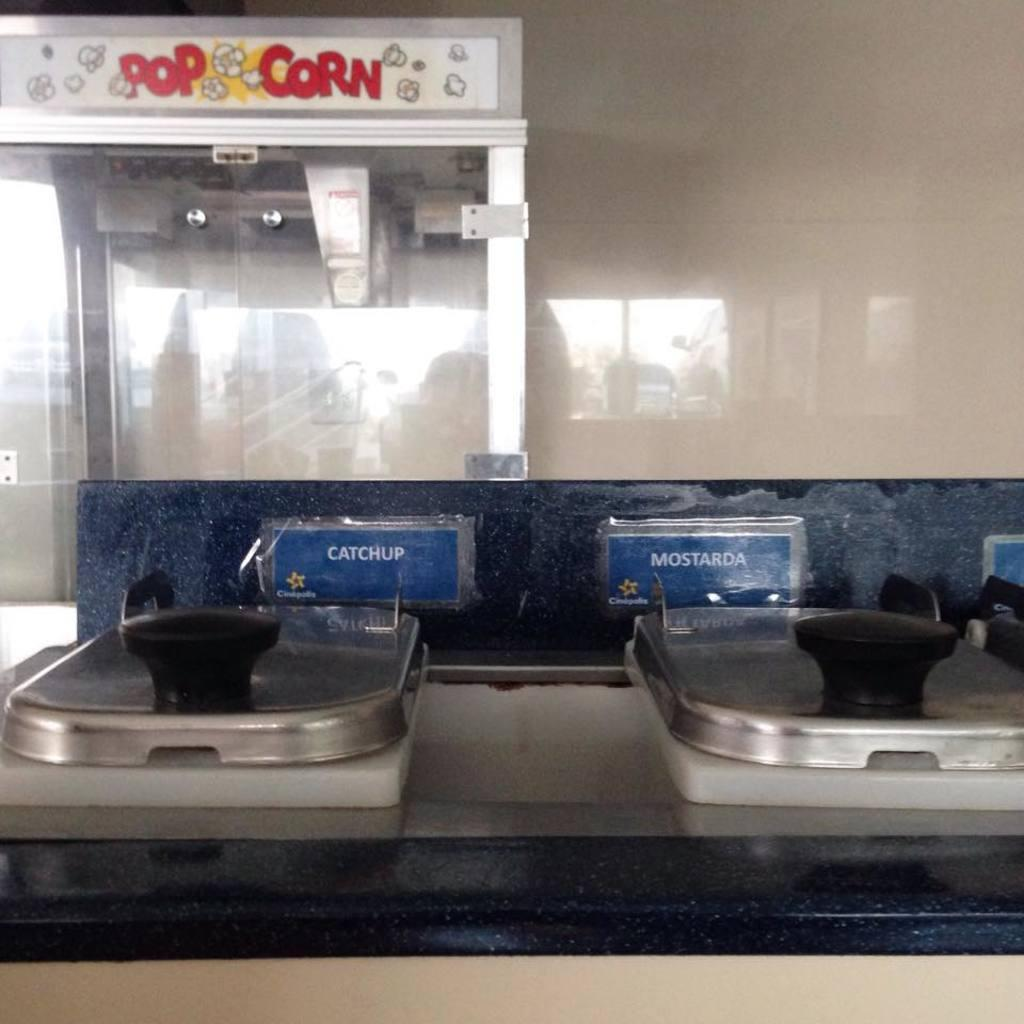<image>
Summarize the visual content of the image. Containers of Ketchup and Mustard are on a counter. 